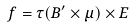<formula> <loc_0><loc_0><loc_500><loc_500>{ f } = \tau ( { B } ^ { \prime } \times { \mu } ) \times { E }</formula> 